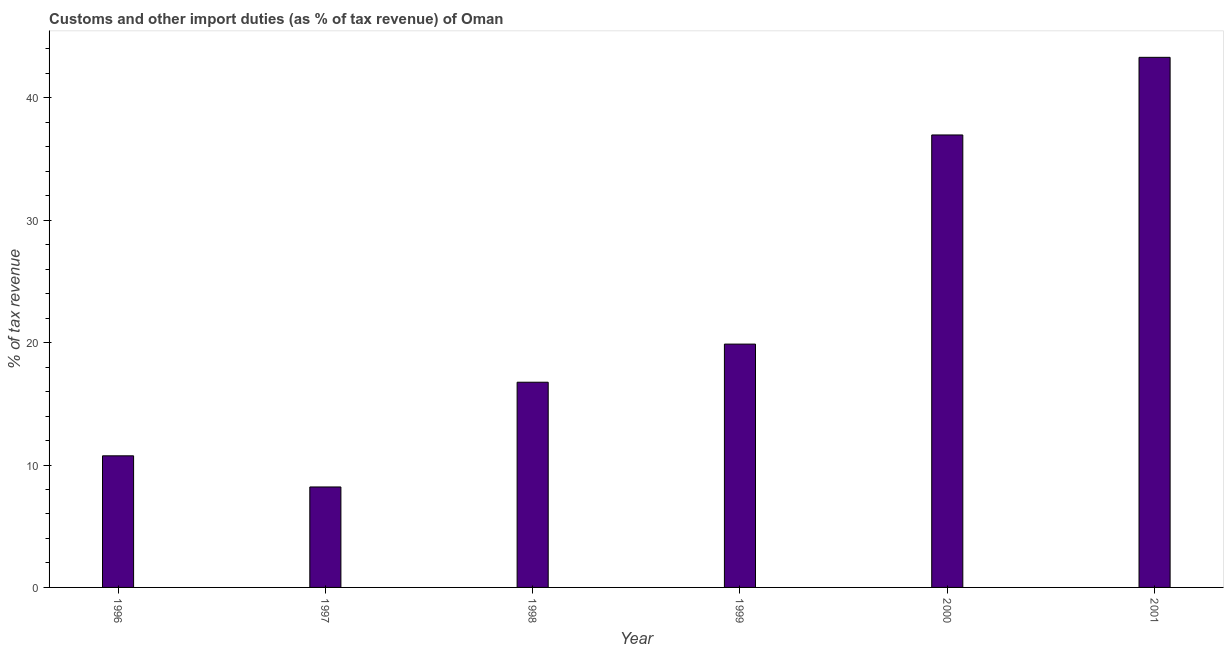Does the graph contain any zero values?
Provide a succinct answer. No. What is the title of the graph?
Offer a terse response. Customs and other import duties (as % of tax revenue) of Oman. What is the label or title of the Y-axis?
Your answer should be compact. % of tax revenue. What is the customs and other import duties in 2001?
Provide a succinct answer. 43.31. Across all years, what is the maximum customs and other import duties?
Give a very brief answer. 43.31. Across all years, what is the minimum customs and other import duties?
Keep it short and to the point. 8.21. In which year was the customs and other import duties maximum?
Your response must be concise. 2001. What is the sum of the customs and other import duties?
Provide a short and direct response. 135.89. What is the difference between the customs and other import duties in 1996 and 1999?
Offer a very short reply. -9.13. What is the average customs and other import duties per year?
Give a very brief answer. 22.65. What is the median customs and other import duties?
Make the answer very short. 18.32. What is the ratio of the customs and other import duties in 1997 to that in 1998?
Offer a very short reply. 0.49. What is the difference between the highest and the second highest customs and other import duties?
Offer a very short reply. 6.34. What is the difference between the highest and the lowest customs and other import duties?
Provide a succinct answer. 35.1. How many years are there in the graph?
Offer a terse response. 6. What is the % of tax revenue of 1996?
Make the answer very short. 10.75. What is the % of tax revenue in 1997?
Your response must be concise. 8.21. What is the % of tax revenue in 1998?
Your answer should be compact. 16.77. What is the % of tax revenue of 1999?
Offer a very short reply. 19.88. What is the % of tax revenue in 2000?
Keep it short and to the point. 36.97. What is the % of tax revenue of 2001?
Provide a succinct answer. 43.31. What is the difference between the % of tax revenue in 1996 and 1997?
Give a very brief answer. 2.54. What is the difference between the % of tax revenue in 1996 and 1998?
Make the answer very short. -6.01. What is the difference between the % of tax revenue in 1996 and 1999?
Provide a short and direct response. -9.13. What is the difference between the % of tax revenue in 1996 and 2000?
Offer a very short reply. -26.22. What is the difference between the % of tax revenue in 1996 and 2001?
Ensure brevity in your answer.  -32.56. What is the difference between the % of tax revenue in 1997 and 1998?
Ensure brevity in your answer.  -8.56. What is the difference between the % of tax revenue in 1997 and 1999?
Keep it short and to the point. -11.67. What is the difference between the % of tax revenue in 1997 and 2000?
Your answer should be compact. -28.76. What is the difference between the % of tax revenue in 1997 and 2001?
Your answer should be very brief. -35.1. What is the difference between the % of tax revenue in 1998 and 1999?
Your answer should be compact. -3.11. What is the difference between the % of tax revenue in 1998 and 2000?
Keep it short and to the point. -20.2. What is the difference between the % of tax revenue in 1998 and 2001?
Make the answer very short. -26.54. What is the difference between the % of tax revenue in 1999 and 2000?
Offer a terse response. -17.09. What is the difference between the % of tax revenue in 1999 and 2001?
Your answer should be very brief. -23.43. What is the difference between the % of tax revenue in 2000 and 2001?
Your answer should be very brief. -6.34. What is the ratio of the % of tax revenue in 1996 to that in 1997?
Offer a very short reply. 1.31. What is the ratio of the % of tax revenue in 1996 to that in 1998?
Offer a terse response. 0.64. What is the ratio of the % of tax revenue in 1996 to that in 1999?
Keep it short and to the point. 0.54. What is the ratio of the % of tax revenue in 1996 to that in 2000?
Your answer should be compact. 0.29. What is the ratio of the % of tax revenue in 1996 to that in 2001?
Ensure brevity in your answer.  0.25. What is the ratio of the % of tax revenue in 1997 to that in 1998?
Your response must be concise. 0.49. What is the ratio of the % of tax revenue in 1997 to that in 1999?
Make the answer very short. 0.41. What is the ratio of the % of tax revenue in 1997 to that in 2000?
Provide a succinct answer. 0.22. What is the ratio of the % of tax revenue in 1997 to that in 2001?
Provide a short and direct response. 0.19. What is the ratio of the % of tax revenue in 1998 to that in 1999?
Ensure brevity in your answer.  0.84. What is the ratio of the % of tax revenue in 1998 to that in 2000?
Give a very brief answer. 0.45. What is the ratio of the % of tax revenue in 1998 to that in 2001?
Provide a succinct answer. 0.39. What is the ratio of the % of tax revenue in 1999 to that in 2000?
Provide a succinct answer. 0.54. What is the ratio of the % of tax revenue in 1999 to that in 2001?
Offer a terse response. 0.46. What is the ratio of the % of tax revenue in 2000 to that in 2001?
Your response must be concise. 0.85. 